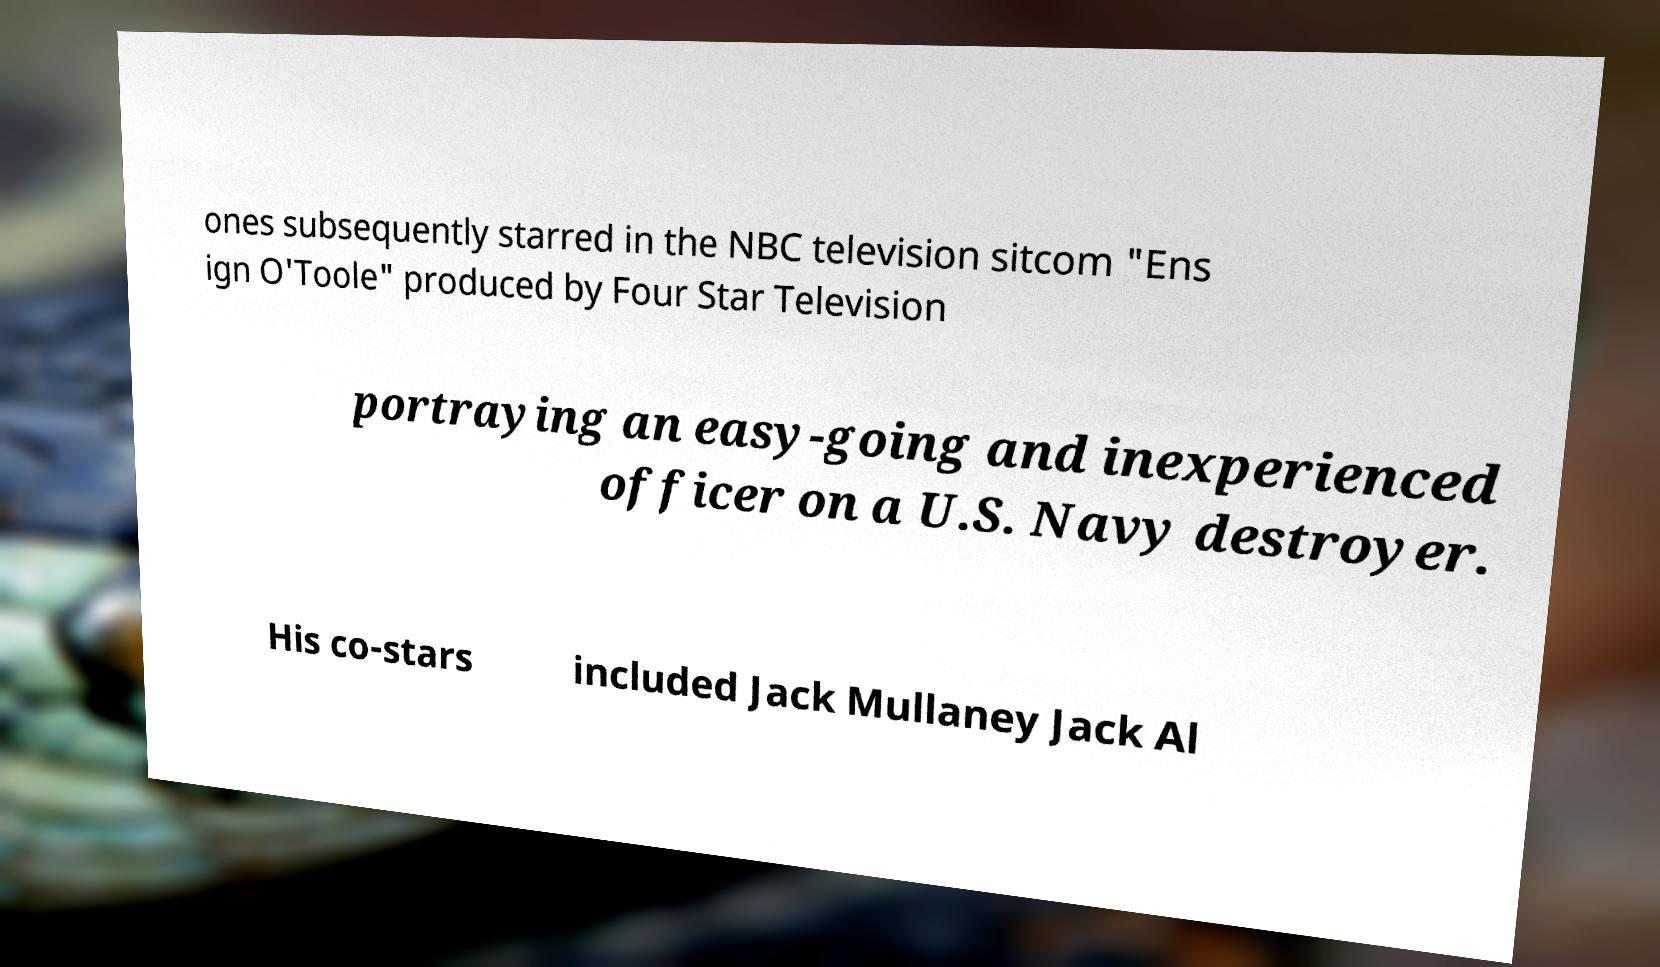There's text embedded in this image that I need extracted. Can you transcribe it verbatim? ones subsequently starred in the NBC television sitcom "Ens ign O'Toole" produced by Four Star Television portraying an easy-going and inexperienced officer on a U.S. Navy destroyer. His co-stars included Jack Mullaney Jack Al 